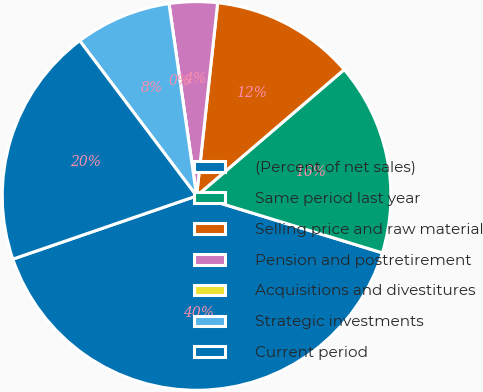Convert chart. <chart><loc_0><loc_0><loc_500><loc_500><pie_chart><fcel>(Percent of net sales)<fcel>Same period last year<fcel>Selling price and raw material<fcel>Pension and postretirement<fcel>Acquisitions and divestitures<fcel>Strategic investments<fcel>Current period<nl><fcel>40.0%<fcel>16.0%<fcel>12.0%<fcel>4.0%<fcel>0.0%<fcel>8.0%<fcel>20.0%<nl></chart> 